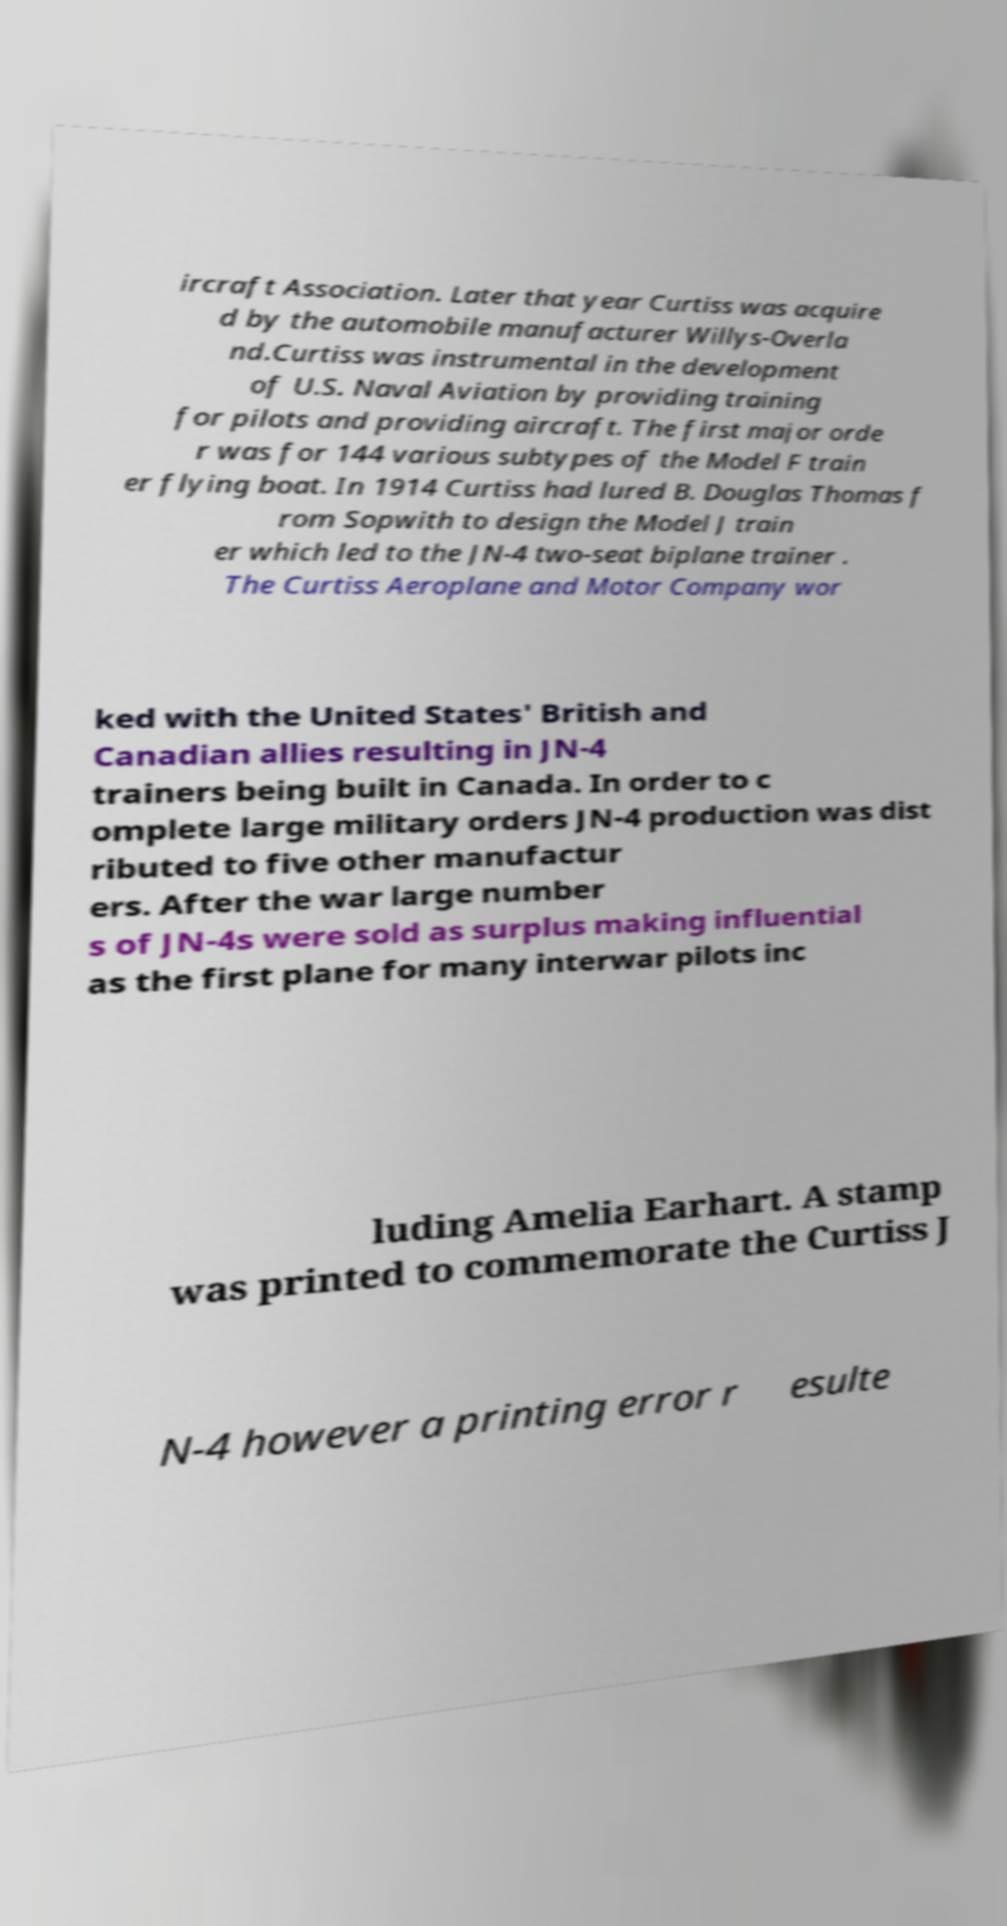Can you read and provide the text displayed in the image?This photo seems to have some interesting text. Can you extract and type it out for me? ircraft Association. Later that year Curtiss was acquire d by the automobile manufacturer Willys-Overla nd.Curtiss was instrumental in the development of U.S. Naval Aviation by providing training for pilots and providing aircraft. The first major orde r was for 144 various subtypes of the Model F train er flying boat. In 1914 Curtiss had lured B. Douglas Thomas f rom Sopwith to design the Model J train er which led to the JN-4 two-seat biplane trainer . The Curtiss Aeroplane and Motor Company wor ked with the United States' British and Canadian allies resulting in JN-4 trainers being built in Canada. In order to c omplete large military orders JN-4 production was dist ributed to five other manufactur ers. After the war large number s of JN-4s were sold as surplus making influential as the first plane for many interwar pilots inc luding Amelia Earhart. A stamp was printed to commemorate the Curtiss J N-4 however a printing error r esulte 